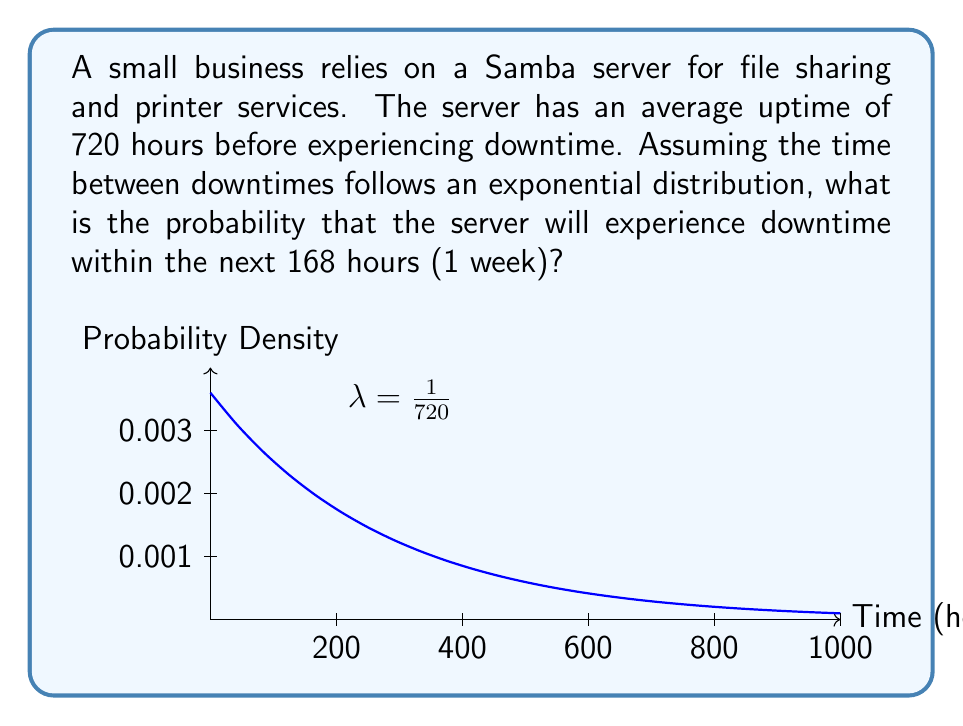Provide a solution to this math problem. Let's approach this step-by-step:

1) The exponential distribution is often used to model the time between events in a Poisson process. In this case, it's modeling the time between server downtimes.

2) The probability density function of an exponential distribution is:

   $$f(x) = λe^{-λx}$$

   where λ is the rate parameter.

3) Given that the average uptime is 720 hours, we can calculate λ:

   $$λ = \frac{1}{\text{average uptime}} = \frac{1}{720}$$

4) The probability of downtime within a specific time t is given by the cumulative distribution function:

   $$P(X \leq t) = 1 - e^{-λt}$$

5) We want to find the probability of downtime within 168 hours, so we substitute t = 168 and λ = 1/720:

   $$P(X \leq 168) = 1 - e^{-\frac{168}{720}}$$

6) Calculating this:

   $$P(X \leq 168) = 1 - e^{-0.2333} \approx 0.2080$$

Therefore, the probability of server downtime within the next 168 hours is approximately 0.2080 or 20.80%.
Answer: $0.2080$ or $20.80\%$ 